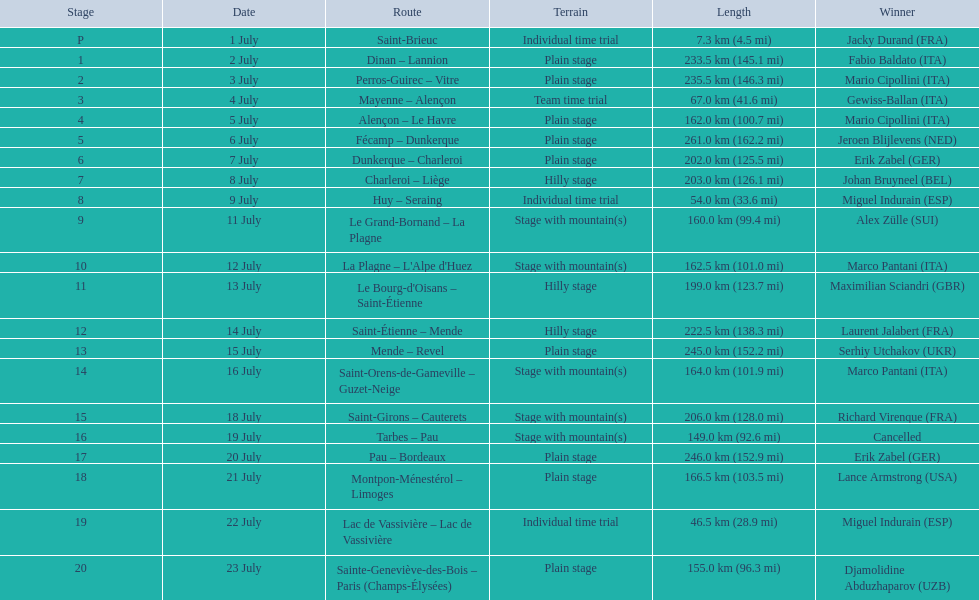How much longer is the 20th tour de france stage than the 19th? 108.5 km. 